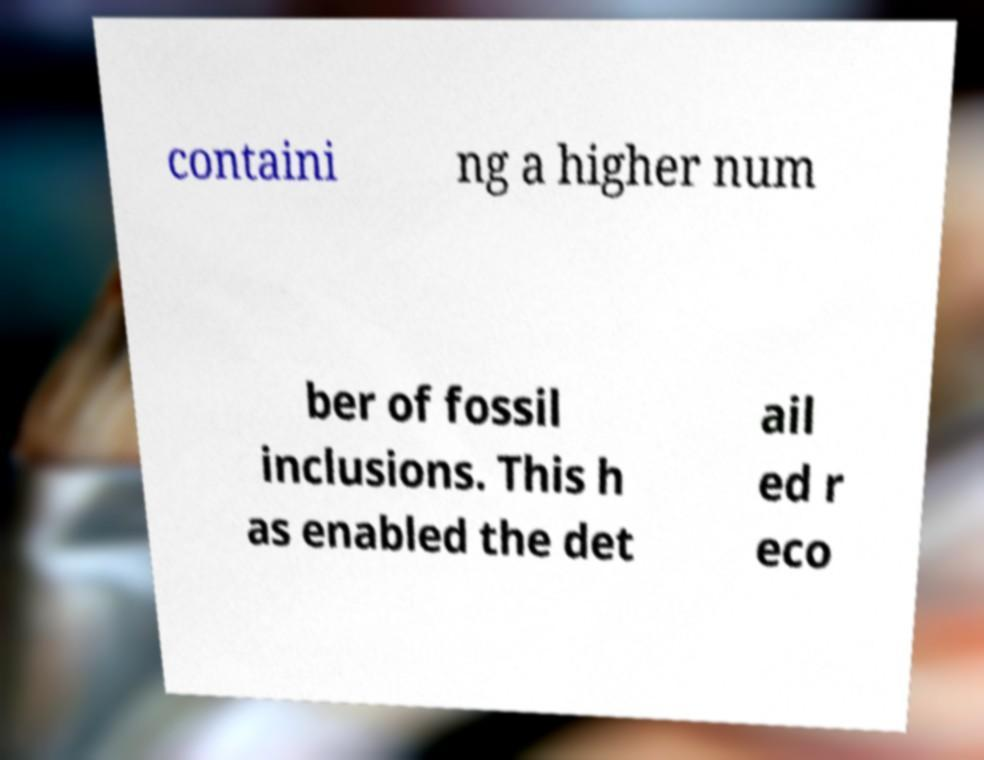What messages or text are displayed in this image? I need them in a readable, typed format. containi ng a higher num ber of fossil inclusions. This h as enabled the det ail ed r eco 